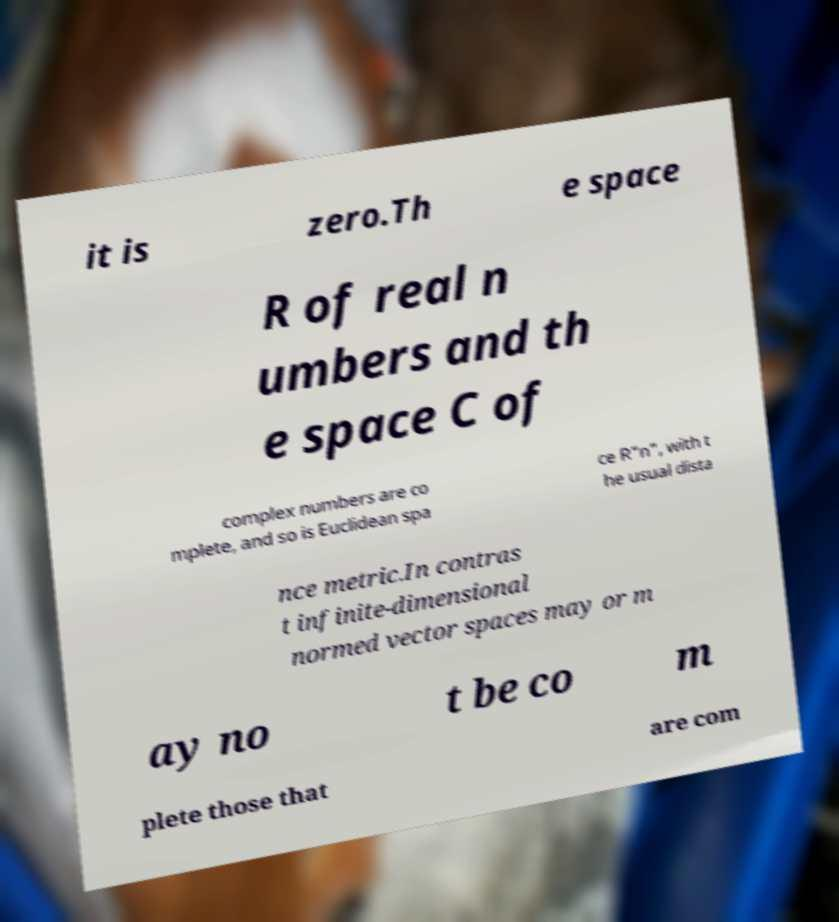For documentation purposes, I need the text within this image transcribed. Could you provide that? it is zero.Th e space R of real n umbers and th e space C of complex numbers are co mplete, and so is Euclidean spa ce R"n", with t he usual dista nce metric.In contras t infinite-dimensional normed vector spaces may or m ay no t be co m plete those that are com 